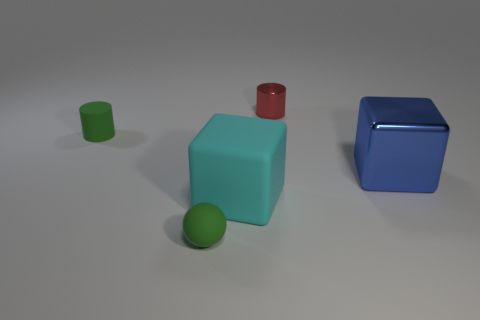Add 4 tiny metallic cylinders. How many objects exist? 9 Subtract all spheres. How many objects are left? 4 Add 1 tiny things. How many tiny things are left? 4 Add 3 tiny cylinders. How many tiny cylinders exist? 5 Subtract 0 green blocks. How many objects are left? 5 Subtract all metallic cylinders. Subtract all metal balls. How many objects are left? 4 